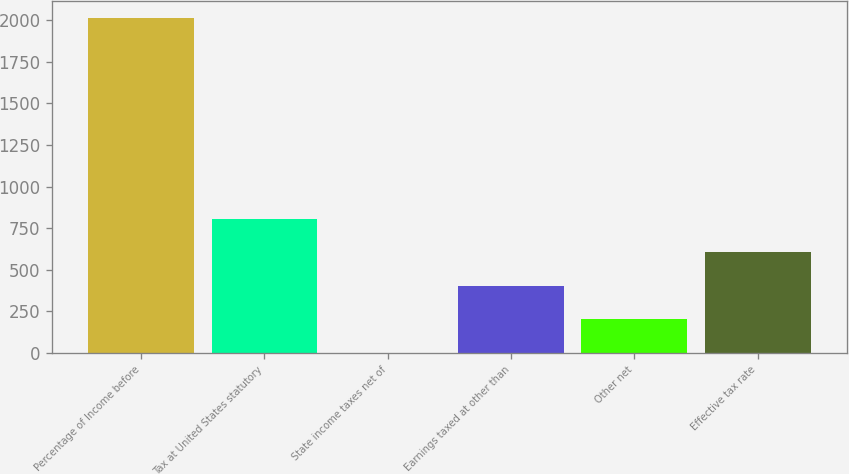Convert chart to OTSL. <chart><loc_0><loc_0><loc_500><loc_500><bar_chart><fcel>Percentage of Income before<fcel>Tax at United States statutory<fcel>State income taxes net of<fcel>Earnings taxed at other than<fcel>Other net<fcel>Effective tax rate<nl><fcel>2014<fcel>806.02<fcel>0.7<fcel>403.36<fcel>202.03<fcel>604.69<nl></chart> 